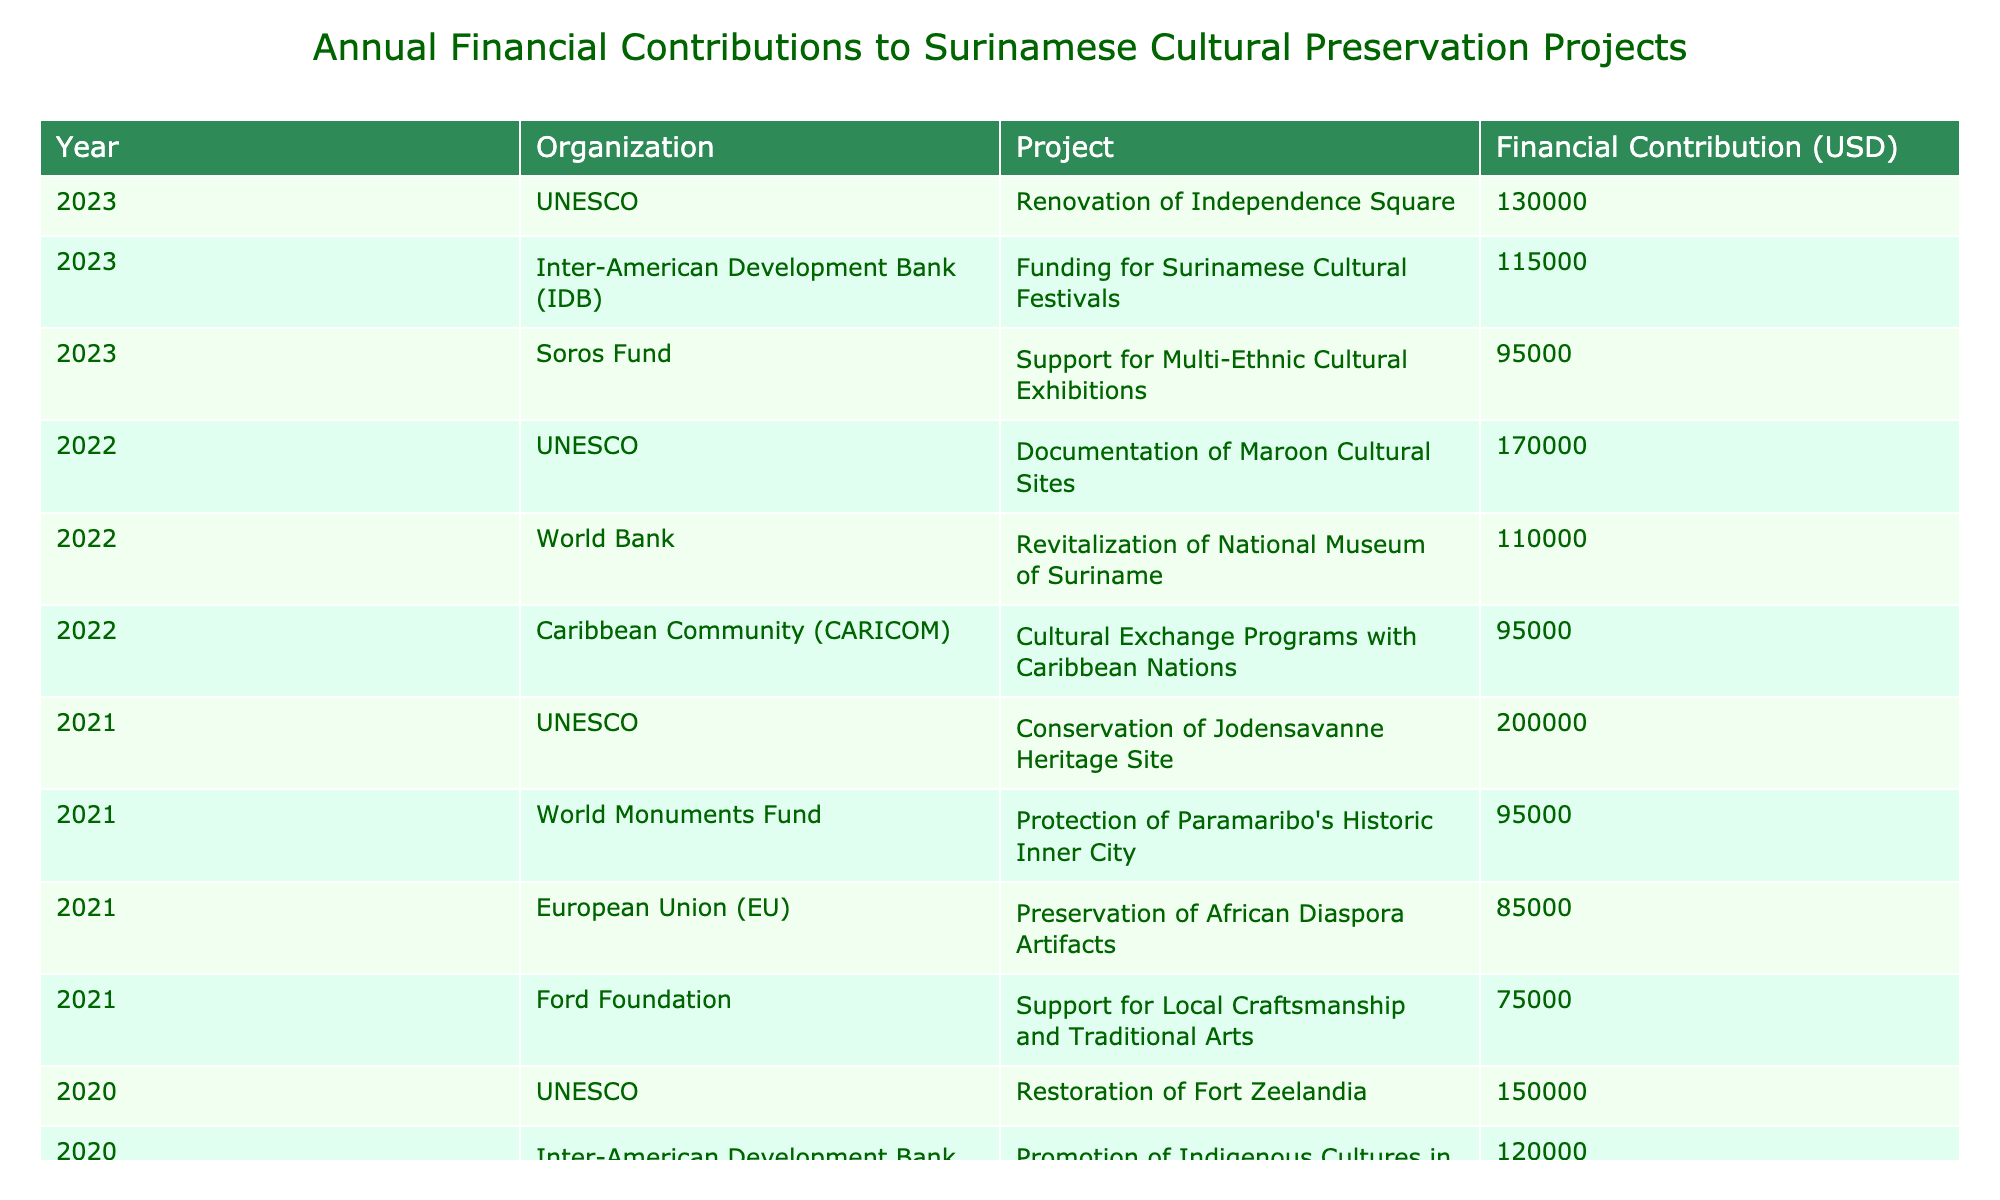What was the total financial contribution for the year 2020? To find the total for 2020, we add the contributions from each organization: 150000 (UNESCO) + 100000 (World Bank) + 120000 (IDB) = 370000.
Answer: 370000 Which organization contributed the most in 2021? From the data for 2021, we see the contributions: UNESCO (200000), EU (85000), World Monuments Fund (95000), and Ford Foundation (75000). The highest contribution is from UNESCO, which is 200000.
Answer: UNESCO Did the World Bank support any projects in 2022? Yes, the data shows that the World Bank contributed 110000 for the revitalization of the National Museum of Suriname in 2022.
Answer: Yes What is the average financial contribution across all years for the Inter-American Development Bank (IDB)? The IDB contributed 120000 in 2020, 0 in 2021, and 115000 in 2023. The average is calculated as (120000 + 0 + 115000) / 3 = 78500.
Answer: 78500 Which year had the lowest total financial contributions, and what was the amount? We can add the contributions for each year: 2020 = 370000, 2021 = 435000, 2022 = 365000, 2023 = 385000. The year with the lowest total contributions is 2022 with 365000.
Answer: 2022, 365000 What percentage of the total contributions in 2023 came from UNESCO? The total contributions in 2023 are 130000 (UNESCO) + 115000 (IDB) + 95000 (Soros Fund) = 340000. The percentage from UNESCO is (130000 / 340000) * 100 = 38.24%.
Answer: 38.24% How many different projects were funded by the European Union (EU)? The table shows that the EU funded only one project, which is the preservation of African Diaspora Artifacts in 2021.
Answer: 1 Which organization contributed the least in 2021? Looking at the contributions for 2021: UNESCO (200000), EU (85000), World Monuments Fund (95000), and Ford Foundation (75000). The organization with the least contribution is the Ford Foundation at 75000.
Answer: Ford Foundation 